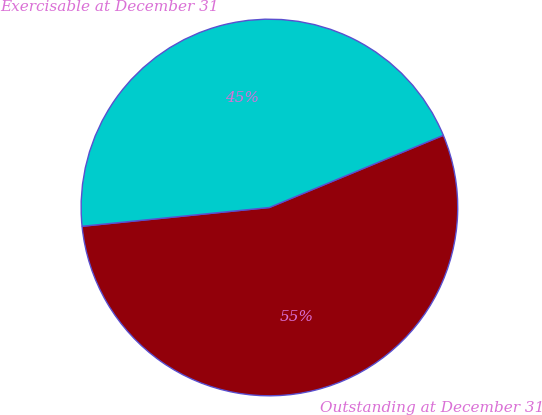Convert chart. <chart><loc_0><loc_0><loc_500><loc_500><pie_chart><fcel>Outstanding at December 31<fcel>Exercisable at December 31<nl><fcel>54.67%<fcel>45.33%<nl></chart> 